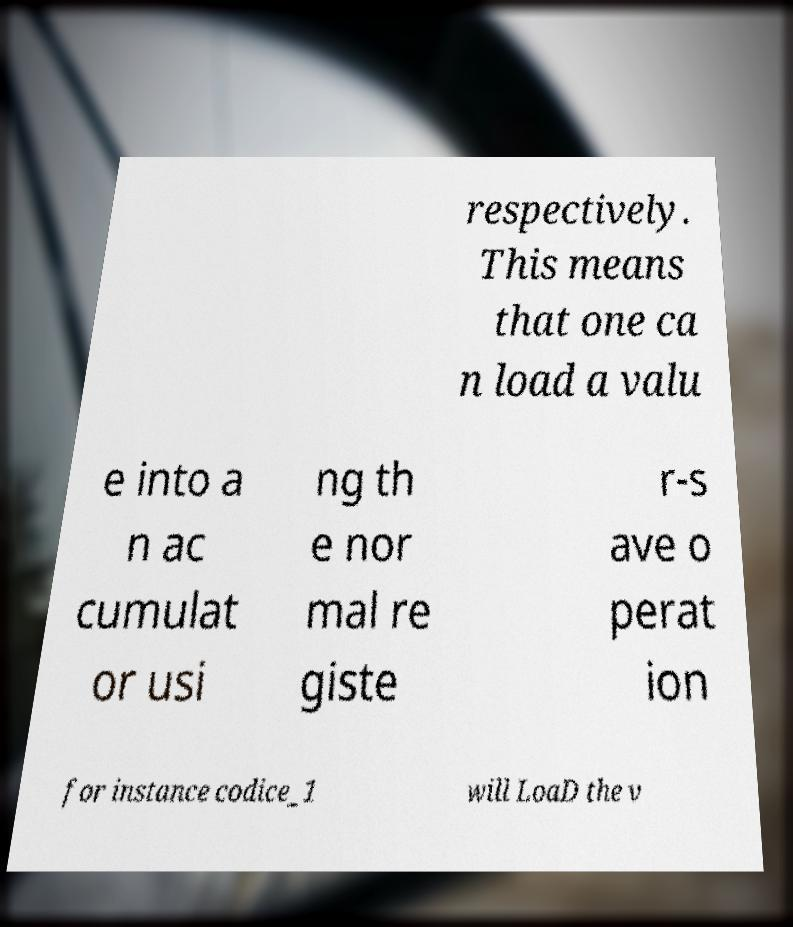Could you extract and type out the text from this image? respectively. This means that one ca n load a valu e into a n ac cumulat or usi ng th e nor mal re giste r-s ave o perat ion for instance codice_1 will LoaD the v 